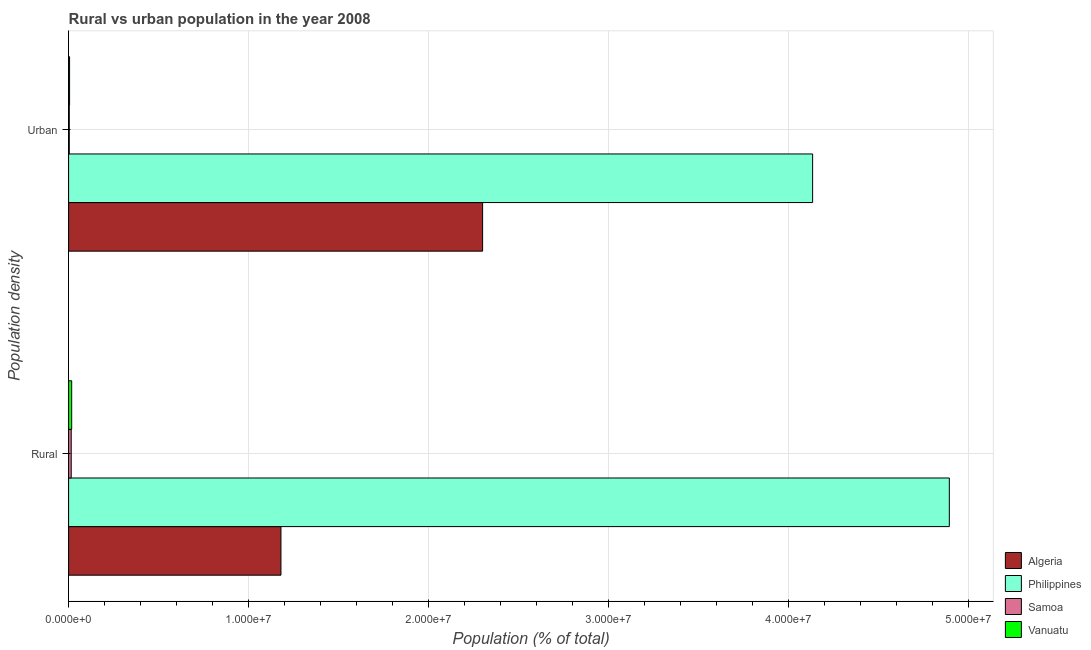How many groups of bars are there?
Your answer should be very brief. 2. What is the label of the 1st group of bars from the top?
Provide a short and direct response. Urban. What is the rural population density in Philippines?
Ensure brevity in your answer.  4.89e+07. Across all countries, what is the maximum rural population density?
Ensure brevity in your answer.  4.89e+07. Across all countries, what is the minimum urban population density?
Provide a short and direct response. 3.76e+04. In which country was the urban population density maximum?
Make the answer very short. Philippines. In which country was the urban population density minimum?
Give a very brief answer. Samoa. What is the total urban population density in the graph?
Provide a succinct answer. 6.45e+07. What is the difference between the rural population density in Algeria and that in Samoa?
Make the answer very short. 1.17e+07. What is the difference between the rural population density in Vanuatu and the urban population density in Philippines?
Your answer should be compact. -4.12e+07. What is the average rural population density per country?
Keep it short and to the point. 1.53e+07. What is the difference between the rural population density and urban population density in Vanuatu?
Make the answer very short. 1.17e+05. In how many countries, is the urban population density greater than 12000000 %?
Your response must be concise. 2. What is the ratio of the rural population density in Algeria to that in Philippines?
Make the answer very short. 0.24. Is the urban population density in Samoa less than that in Algeria?
Ensure brevity in your answer.  Yes. What does the 3rd bar from the bottom in Rural represents?
Make the answer very short. Samoa. What is the difference between two consecutive major ticks on the X-axis?
Provide a short and direct response. 1.00e+07. Are the values on the major ticks of X-axis written in scientific E-notation?
Give a very brief answer. Yes. Does the graph contain any zero values?
Give a very brief answer. No. Does the graph contain grids?
Your answer should be very brief. Yes. Where does the legend appear in the graph?
Offer a very short reply. Bottom right. How many legend labels are there?
Give a very brief answer. 4. How are the legend labels stacked?
Provide a succinct answer. Vertical. What is the title of the graph?
Offer a very short reply. Rural vs urban population in the year 2008. What is the label or title of the X-axis?
Keep it short and to the point. Population (% of total). What is the label or title of the Y-axis?
Provide a short and direct response. Population density. What is the Population (% of total) of Algeria in Rural?
Offer a terse response. 1.18e+07. What is the Population (% of total) in Philippines in Rural?
Offer a very short reply. 4.89e+07. What is the Population (% of total) in Samoa in Rural?
Make the answer very short. 1.46e+05. What is the Population (% of total) in Vanuatu in Rural?
Your answer should be very brief. 1.71e+05. What is the Population (% of total) in Algeria in Urban?
Give a very brief answer. 2.30e+07. What is the Population (% of total) of Philippines in Urban?
Provide a short and direct response. 4.13e+07. What is the Population (% of total) of Samoa in Urban?
Your answer should be compact. 3.76e+04. What is the Population (% of total) in Vanuatu in Urban?
Offer a very short reply. 5.40e+04. Across all Population density, what is the maximum Population (% of total) of Algeria?
Ensure brevity in your answer.  2.30e+07. Across all Population density, what is the maximum Population (% of total) in Philippines?
Ensure brevity in your answer.  4.89e+07. Across all Population density, what is the maximum Population (% of total) of Samoa?
Your response must be concise. 1.46e+05. Across all Population density, what is the maximum Population (% of total) in Vanuatu?
Your response must be concise. 1.71e+05. Across all Population density, what is the minimum Population (% of total) in Algeria?
Give a very brief answer. 1.18e+07. Across all Population density, what is the minimum Population (% of total) in Philippines?
Make the answer very short. 4.13e+07. Across all Population density, what is the minimum Population (% of total) of Samoa?
Your answer should be compact. 3.76e+04. Across all Population density, what is the minimum Population (% of total) in Vanuatu?
Give a very brief answer. 5.40e+04. What is the total Population (% of total) in Algeria in the graph?
Offer a terse response. 3.48e+07. What is the total Population (% of total) in Philippines in the graph?
Offer a terse response. 9.03e+07. What is the total Population (% of total) in Samoa in the graph?
Make the answer very short. 1.83e+05. What is the total Population (% of total) of Vanuatu in the graph?
Offer a very short reply. 2.25e+05. What is the difference between the Population (% of total) of Algeria in Rural and that in Urban?
Keep it short and to the point. -1.12e+07. What is the difference between the Population (% of total) of Philippines in Rural and that in Urban?
Make the answer very short. 7.60e+06. What is the difference between the Population (% of total) of Samoa in Rural and that in Urban?
Offer a very short reply. 1.08e+05. What is the difference between the Population (% of total) of Vanuatu in Rural and that in Urban?
Ensure brevity in your answer.  1.17e+05. What is the difference between the Population (% of total) of Algeria in Rural and the Population (% of total) of Philippines in Urban?
Ensure brevity in your answer.  -2.95e+07. What is the difference between the Population (% of total) of Algeria in Rural and the Population (% of total) of Samoa in Urban?
Ensure brevity in your answer.  1.18e+07. What is the difference between the Population (% of total) of Algeria in Rural and the Population (% of total) of Vanuatu in Urban?
Provide a succinct answer. 1.17e+07. What is the difference between the Population (% of total) of Philippines in Rural and the Population (% of total) of Samoa in Urban?
Offer a terse response. 4.89e+07. What is the difference between the Population (% of total) of Philippines in Rural and the Population (% of total) of Vanuatu in Urban?
Offer a very short reply. 4.89e+07. What is the difference between the Population (% of total) of Samoa in Rural and the Population (% of total) of Vanuatu in Urban?
Keep it short and to the point. 9.17e+04. What is the average Population (% of total) in Algeria per Population density?
Make the answer very short. 1.74e+07. What is the average Population (% of total) of Philippines per Population density?
Your response must be concise. 4.51e+07. What is the average Population (% of total) of Samoa per Population density?
Give a very brief answer. 9.17e+04. What is the average Population (% of total) of Vanuatu per Population density?
Give a very brief answer. 1.13e+05. What is the difference between the Population (% of total) of Algeria and Population (% of total) of Philippines in Rural?
Offer a very short reply. -3.71e+07. What is the difference between the Population (% of total) in Algeria and Population (% of total) in Samoa in Rural?
Your answer should be compact. 1.17e+07. What is the difference between the Population (% of total) in Algeria and Population (% of total) in Vanuatu in Rural?
Provide a succinct answer. 1.16e+07. What is the difference between the Population (% of total) in Philippines and Population (% of total) in Samoa in Rural?
Offer a terse response. 4.88e+07. What is the difference between the Population (% of total) in Philippines and Population (% of total) in Vanuatu in Rural?
Offer a very short reply. 4.88e+07. What is the difference between the Population (% of total) in Samoa and Population (% of total) in Vanuatu in Rural?
Offer a very short reply. -2.55e+04. What is the difference between the Population (% of total) of Algeria and Population (% of total) of Philippines in Urban?
Offer a very short reply. -1.83e+07. What is the difference between the Population (% of total) in Algeria and Population (% of total) in Samoa in Urban?
Your answer should be compact. 2.30e+07. What is the difference between the Population (% of total) in Algeria and Population (% of total) in Vanuatu in Urban?
Give a very brief answer. 2.30e+07. What is the difference between the Population (% of total) of Philippines and Population (% of total) of Samoa in Urban?
Provide a succinct answer. 4.13e+07. What is the difference between the Population (% of total) of Philippines and Population (% of total) of Vanuatu in Urban?
Make the answer very short. 4.13e+07. What is the difference between the Population (% of total) in Samoa and Population (% of total) in Vanuatu in Urban?
Your response must be concise. -1.64e+04. What is the ratio of the Population (% of total) of Algeria in Rural to that in Urban?
Make the answer very short. 0.51. What is the ratio of the Population (% of total) in Philippines in Rural to that in Urban?
Provide a short and direct response. 1.18. What is the ratio of the Population (% of total) in Samoa in Rural to that in Urban?
Ensure brevity in your answer.  3.87. What is the ratio of the Population (% of total) of Vanuatu in Rural to that in Urban?
Provide a short and direct response. 3.17. What is the difference between the highest and the second highest Population (% of total) of Algeria?
Ensure brevity in your answer.  1.12e+07. What is the difference between the highest and the second highest Population (% of total) in Philippines?
Give a very brief answer. 7.60e+06. What is the difference between the highest and the second highest Population (% of total) of Samoa?
Provide a short and direct response. 1.08e+05. What is the difference between the highest and the second highest Population (% of total) of Vanuatu?
Keep it short and to the point. 1.17e+05. What is the difference between the highest and the lowest Population (% of total) in Algeria?
Keep it short and to the point. 1.12e+07. What is the difference between the highest and the lowest Population (% of total) in Philippines?
Offer a terse response. 7.60e+06. What is the difference between the highest and the lowest Population (% of total) in Samoa?
Ensure brevity in your answer.  1.08e+05. What is the difference between the highest and the lowest Population (% of total) of Vanuatu?
Provide a succinct answer. 1.17e+05. 